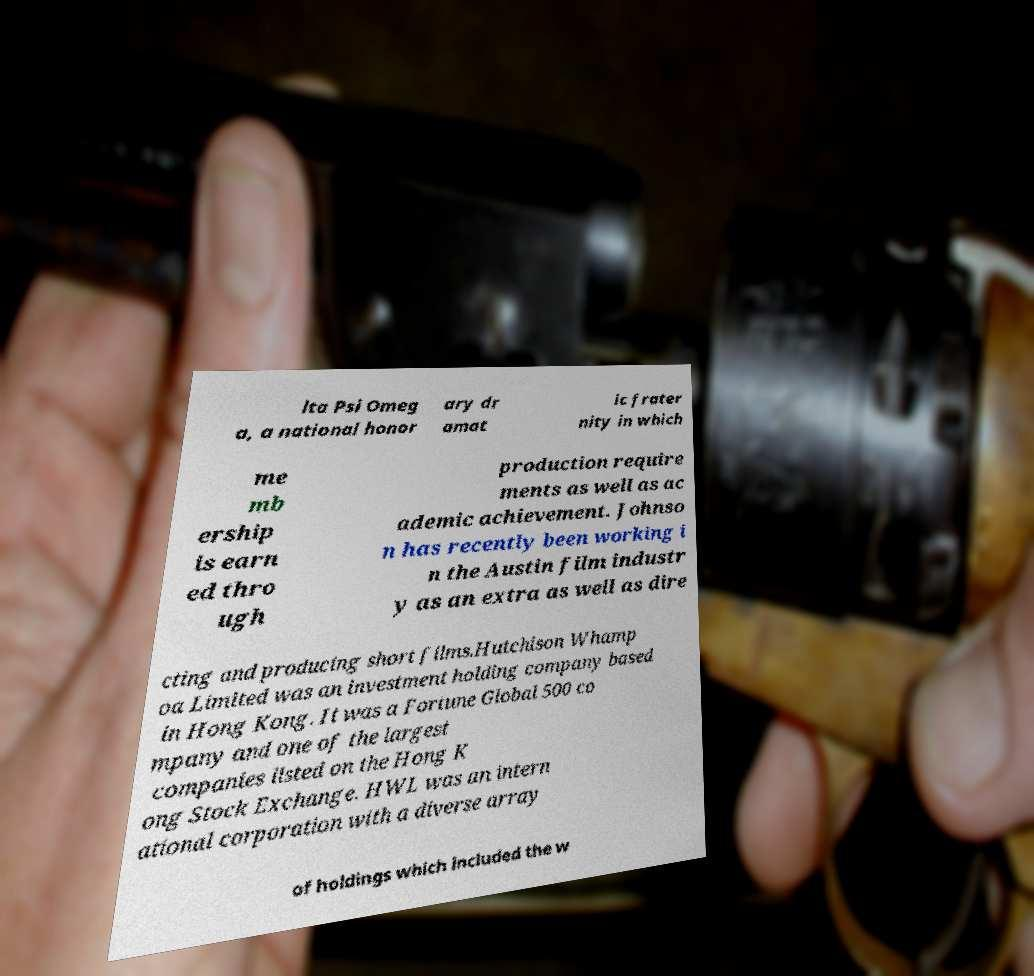Could you assist in decoding the text presented in this image and type it out clearly? lta Psi Omeg a, a national honor ary dr amat ic frater nity in which me mb ership is earn ed thro ugh production require ments as well as ac ademic achievement. Johnso n has recently been working i n the Austin film industr y as an extra as well as dire cting and producing short films.Hutchison Whamp oa Limited was an investment holding company based in Hong Kong. It was a Fortune Global 500 co mpany and one of the largest companies listed on the Hong K ong Stock Exchange. HWL was an intern ational corporation with a diverse array of holdings which included the w 